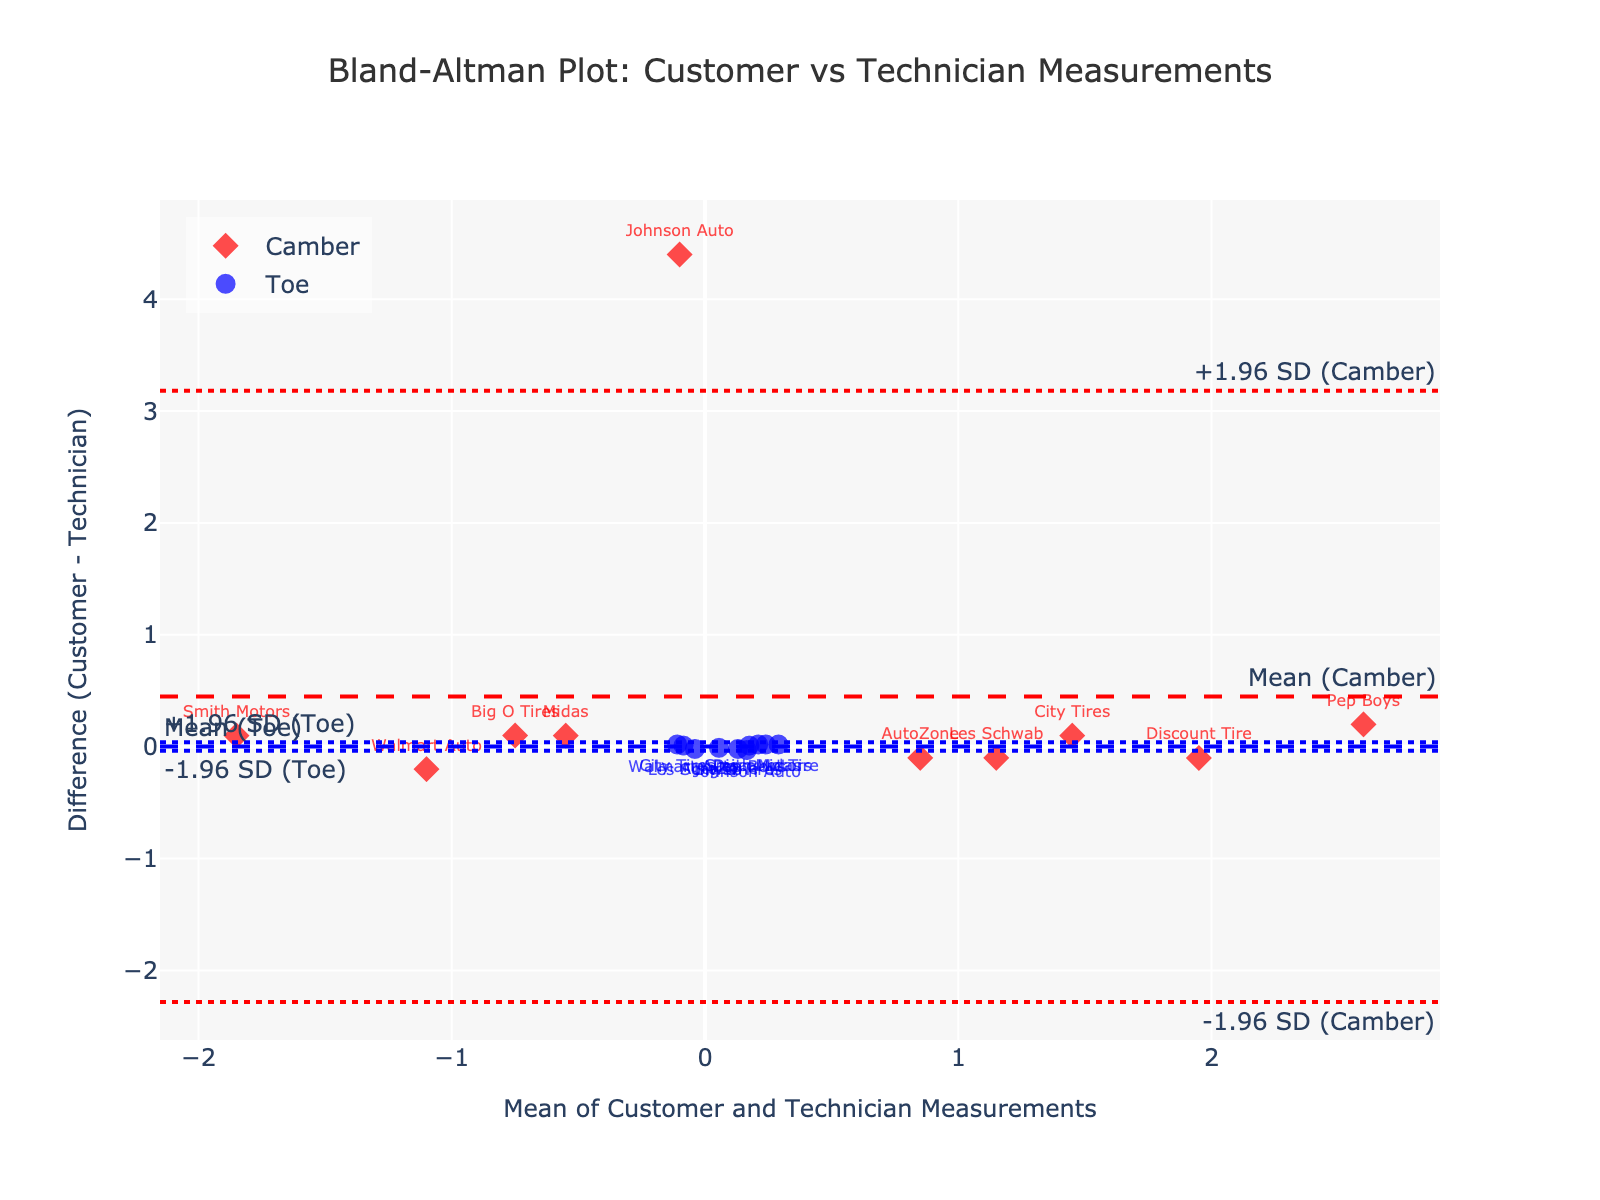What's the title of the figure? The title is usually located at the top of the figure. It reads "Bland-Altman Plot: Customer vs Technician Measurements".
Answer: Bland-Altman Plot: Customer vs Technician Measurements What are the variables compared in this Bland-Altman plot? The plot compares "Camber" and "Toe" measurements from customers and technicians.
Answer: Camber and Toe Which customer has the highest positive difference in Camber measurements? By looking at the red diamonds on the plot, we can see that the Pep Boys customer has the highest positive difference in Camber measurements, indicated by the highest red marker above the mean.
Answer: Pep Boys Which customer shows the smallest difference in Toe measurements? Observing the blue circles on the plot, the customer "AutoZone" appears to be closest to the horizontal mean line, indicating the smallest difference in Toe measurements.
Answer: AutoZone What do the dashed and dotted horizontal lines represent on the plot? The dashed line represents the mean difference for both Camber and Toe measurements, while the dotted lines indicate the limits of agreement (-1.96 and +1.96 standard deviations from the mean).
Answer: Mean difference and limits of agreement How many customers have a positive difference in Camber measurements? Counting the red diamonds that are above the mean line (horizontal dashed red line) shows the number of customers with positive Camber differences. There are five such customers.
Answer: 5 What's the difference range for Toe measurements considering the limits of agreement? The limits of agreement are marked by the dotted blue lines. The lower limit is around -0.05 and the upper limit is around 0.08, calculated using the mean difference +/- 1.96 SD.
Answer: -0.05 to 0.08 Is there any customer whose measurements fall outside the limits of agreement for Toe? To check this, observe if any of the blue circles fall outside the dotted blue lines. None of the blue markers exceed these limits.
Answer: No Which type of measurement shows the most variability among customers? By comparing the spread of red diamonds (Camber) and blue circles (Toe), we can see that the differences in Camber are more spread out or variable.
Answer: Camber Are the average differences for Camber and Toe similar? The mean lines for both Camber and Toe approximate the overall trends. The lines appear to be centered closely around zero, indicating similar average differences.
Answer: Yes 